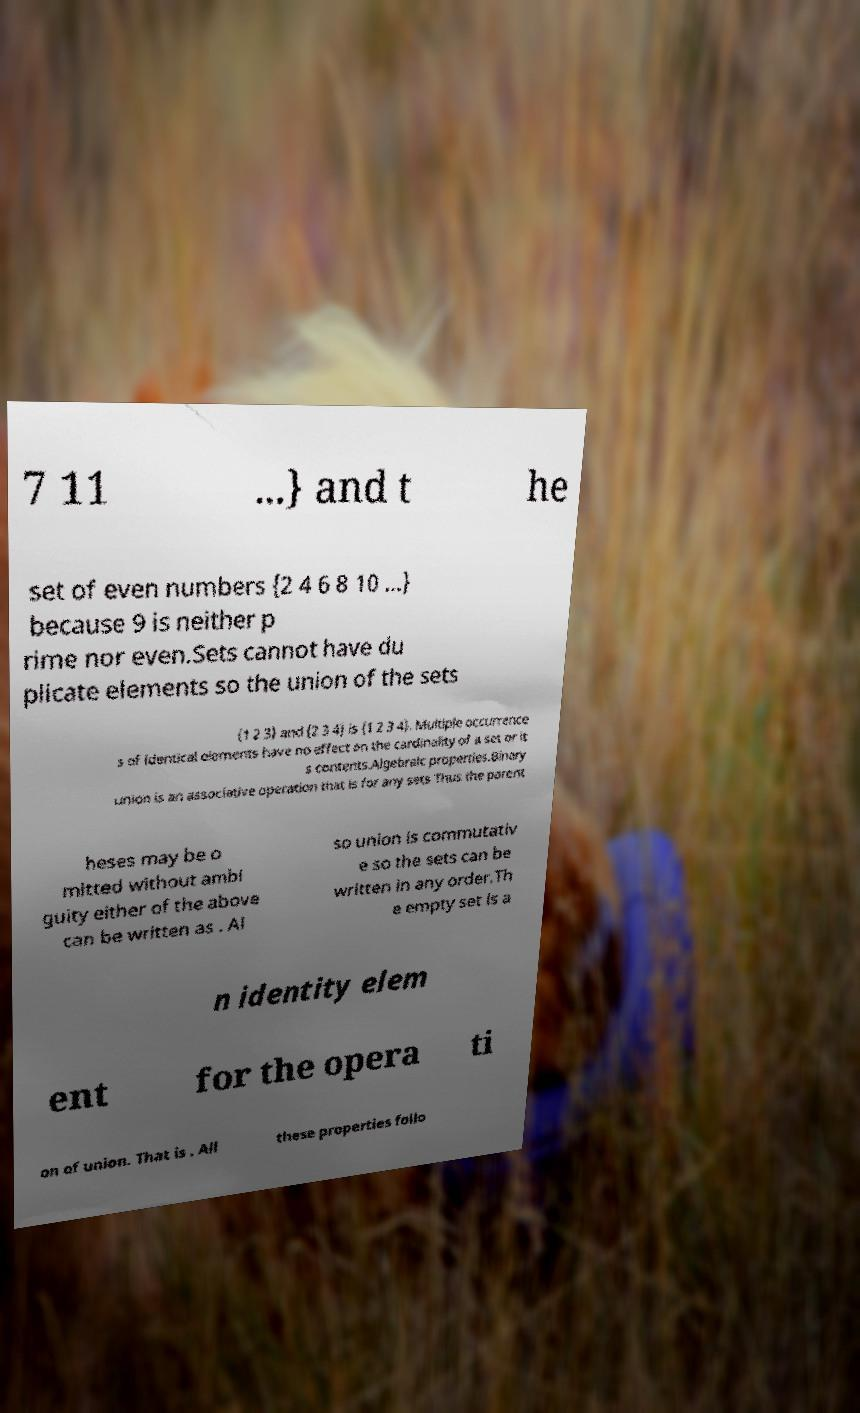For documentation purposes, I need the text within this image transcribed. Could you provide that? 7 11 ...} and t he set of even numbers {2 4 6 8 10 ...} because 9 is neither p rime nor even.Sets cannot have du plicate elements so the union of the sets {1 2 3} and {2 3 4} is {1 2 3 4}. Multiple occurrence s of identical elements have no effect on the cardinality of a set or it s contents.Algebraic properties.Binary union is an associative operation that is for any sets Thus the parent heses may be o mitted without ambi guity either of the above can be written as . Al so union is commutativ e so the sets can be written in any order.Th e empty set is a n identity elem ent for the opera ti on of union. That is . All these properties follo 